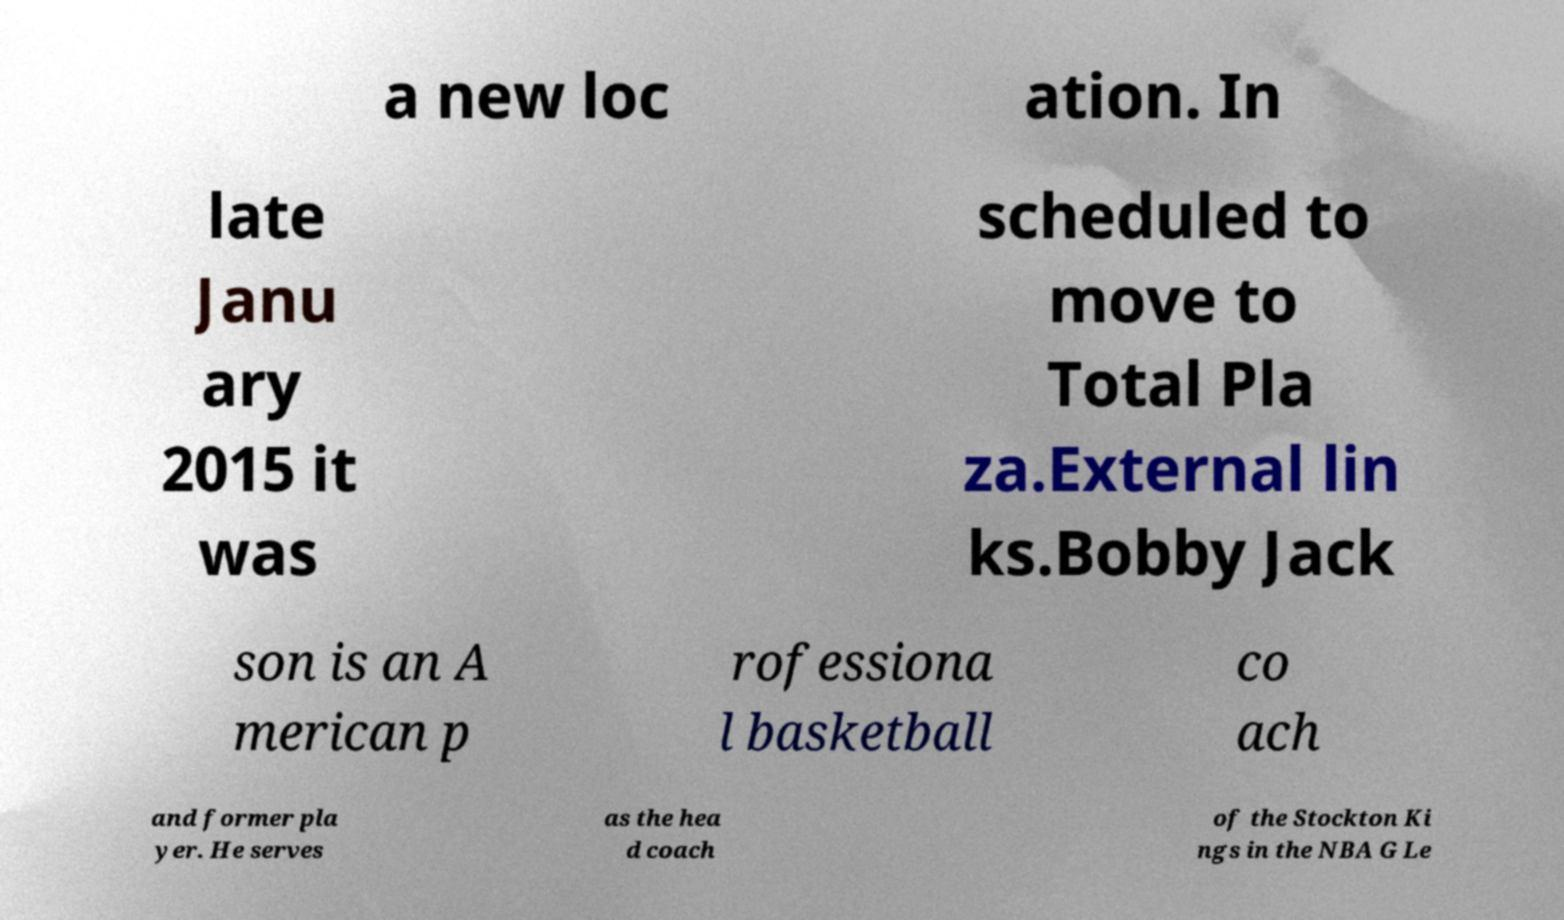Please read and relay the text visible in this image. What does it say? a new loc ation. In late Janu ary 2015 it was scheduled to move to Total Pla za.External lin ks.Bobby Jack son is an A merican p rofessiona l basketball co ach and former pla yer. He serves as the hea d coach of the Stockton Ki ngs in the NBA G Le 